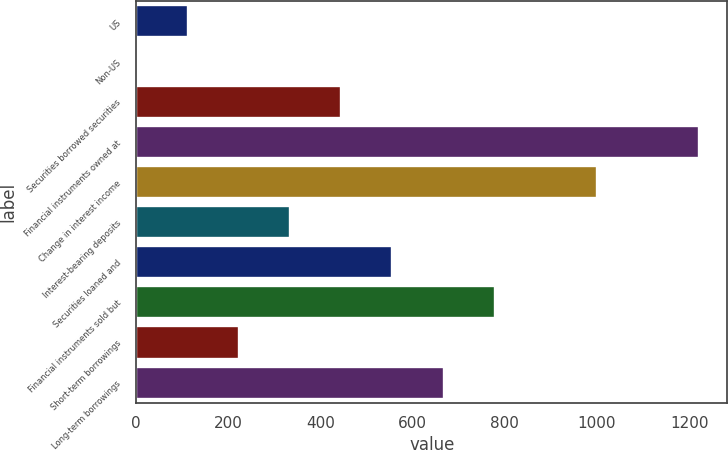Convert chart. <chart><loc_0><loc_0><loc_500><loc_500><bar_chart><fcel>US<fcel>Non-US<fcel>Securities borrowed securities<fcel>Financial instruments owned at<fcel>Change in interest income<fcel>Interest-bearing deposits<fcel>Securities loaned and<fcel>Financial instruments sold but<fcel>Short-term borrowings<fcel>Long-term borrowings<nl><fcel>112<fcel>1<fcel>445<fcel>1222<fcel>1000<fcel>334<fcel>556<fcel>778<fcel>223<fcel>667<nl></chart> 